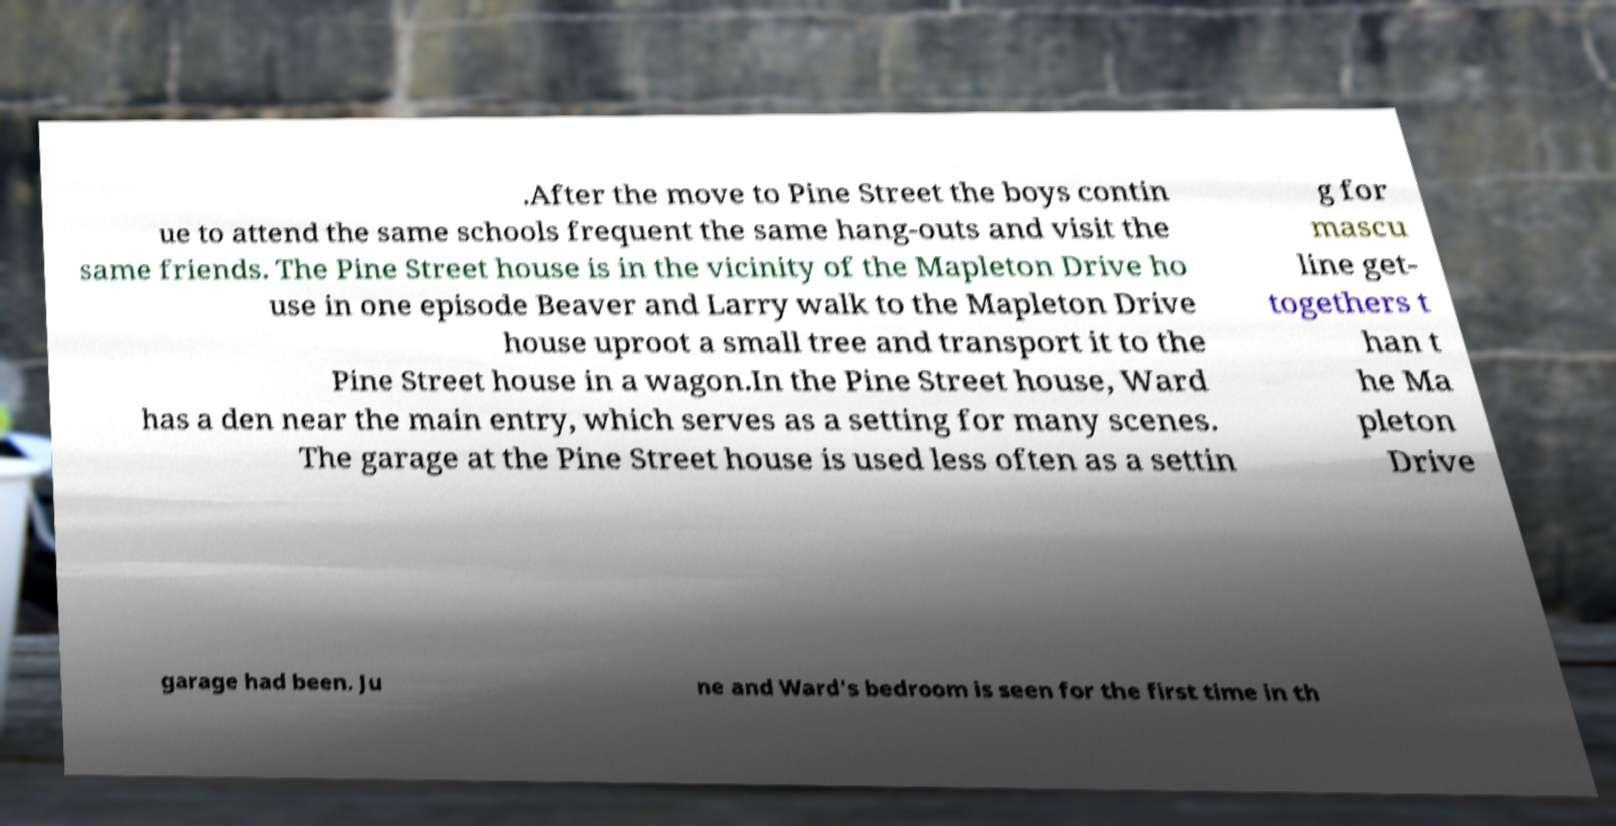Please read and relay the text visible in this image. What does it say? .After the move to Pine Street the boys contin ue to attend the same schools frequent the same hang-outs and visit the same friends. The Pine Street house is in the vicinity of the Mapleton Drive ho use in one episode Beaver and Larry walk to the Mapleton Drive house uproot a small tree and transport it to the Pine Street house in a wagon.In the Pine Street house, Ward has a den near the main entry, which serves as a setting for many scenes. The garage at the Pine Street house is used less often as a settin g for mascu line get- togethers t han t he Ma pleton Drive garage had been. Ju ne and Ward's bedroom is seen for the first time in th 